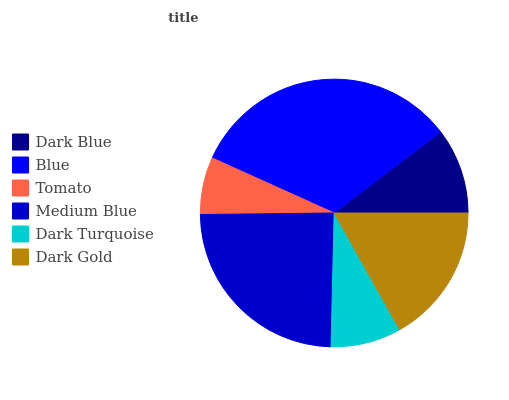Is Tomato the minimum?
Answer yes or no. Yes. Is Blue the maximum?
Answer yes or no. Yes. Is Blue the minimum?
Answer yes or no. No. Is Tomato the maximum?
Answer yes or no. No. Is Blue greater than Tomato?
Answer yes or no. Yes. Is Tomato less than Blue?
Answer yes or no. Yes. Is Tomato greater than Blue?
Answer yes or no. No. Is Blue less than Tomato?
Answer yes or no. No. Is Dark Gold the high median?
Answer yes or no. Yes. Is Dark Blue the low median?
Answer yes or no. Yes. Is Medium Blue the high median?
Answer yes or no. No. Is Medium Blue the low median?
Answer yes or no. No. 